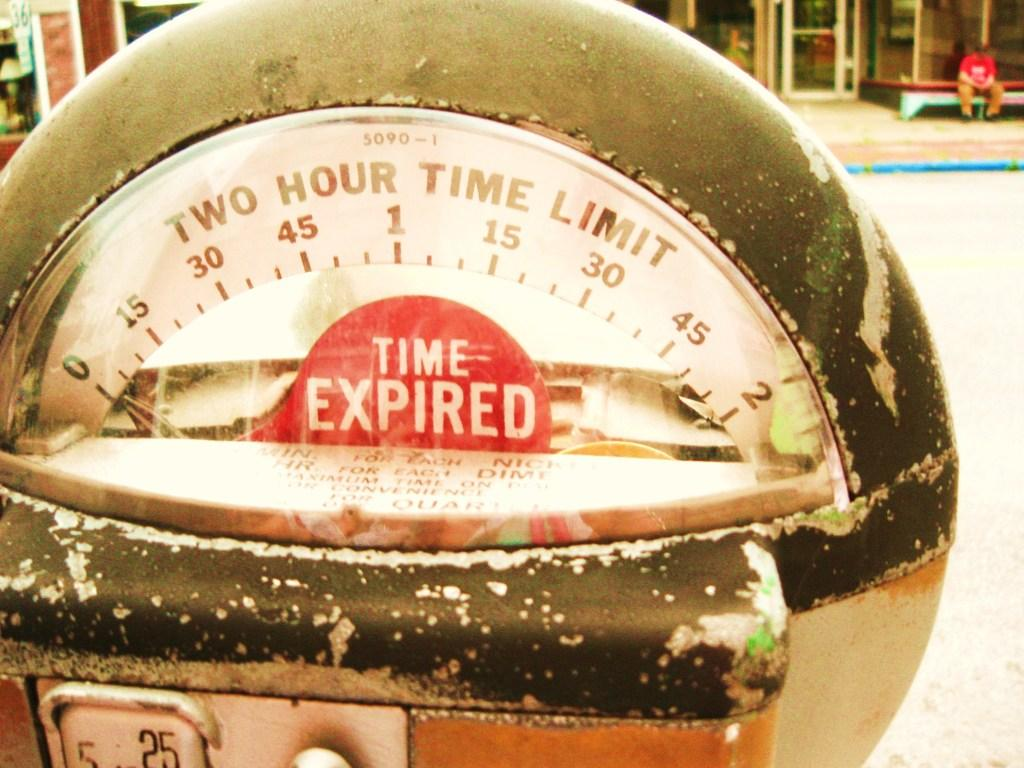<image>
Render a clear and concise summary of the photo. The parking meter shown is showing the time expired sign. 